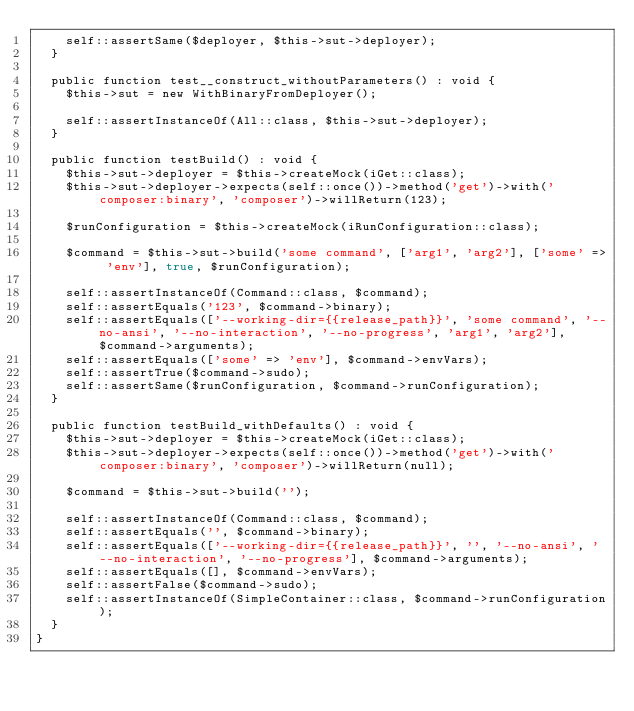<code> <loc_0><loc_0><loc_500><loc_500><_PHP_>    self::assertSame($deployer, $this->sut->deployer);
  }

  public function test__construct_withoutParameters() : void {
    $this->sut = new WithBinaryFromDeployer();

    self::assertInstanceOf(All::class, $this->sut->deployer);
  }

  public function testBuild() : void {
    $this->sut->deployer = $this->createMock(iGet::class);
    $this->sut->deployer->expects(self::once())->method('get')->with('composer:binary', 'composer')->willReturn(123);

    $runConfiguration = $this->createMock(iRunConfiguration::class);

    $command = $this->sut->build('some command', ['arg1', 'arg2'], ['some' => 'env'], true, $runConfiguration);

    self::assertInstanceOf(Command::class, $command);
    self::assertEquals('123', $command->binary);
    self::assertEquals(['--working-dir={{release_path}}', 'some command', '--no-ansi', '--no-interaction', '--no-progress', 'arg1', 'arg2'], $command->arguments);
    self::assertEquals(['some' => 'env'], $command->envVars);
    self::assertTrue($command->sudo);
    self::assertSame($runConfiguration, $command->runConfiguration);
  }

  public function testBuild_withDefaults() : void {
    $this->sut->deployer = $this->createMock(iGet::class);
    $this->sut->deployer->expects(self::once())->method('get')->with('composer:binary', 'composer')->willReturn(null);

    $command = $this->sut->build('');

    self::assertInstanceOf(Command::class, $command);
    self::assertEquals('', $command->binary);
    self::assertEquals(['--working-dir={{release_path}}', '', '--no-ansi', '--no-interaction', '--no-progress'], $command->arguments);
    self::assertEquals([], $command->envVars);
    self::assertFalse($command->sudo);
    self::assertInstanceOf(SimpleContainer::class, $command->runConfiguration);
  }
}
</code> 